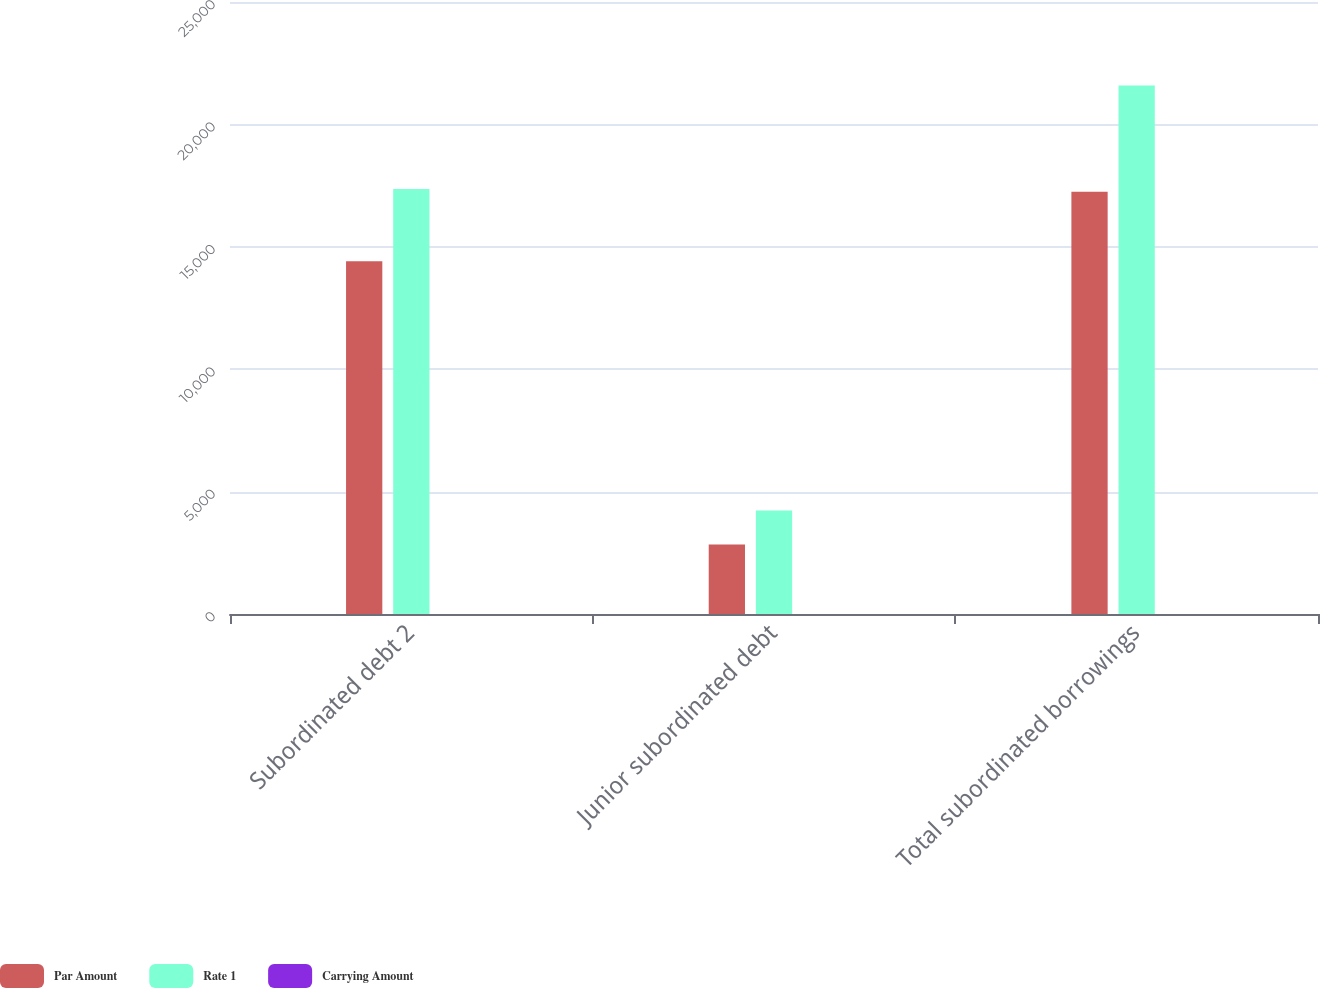<chart> <loc_0><loc_0><loc_500><loc_500><stacked_bar_chart><ecel><fcel>Subordinated debt 2<fcel>Junior subordinated debt<fcel>Total subordinated borrowings<nl><fcel>Par Amount<fcel>14409<fcel>2835<fcel>17244<nl><fcel>Rate 1<fcel>17358<fcel>4228<fcel>21586<nl><fcel>Carrying Amount<fcel>4.24<fcel>3.16<fcel>4.06<nl></chart> 